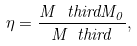<formula> <loc_0><loc_0><loc_500><loc_500>\eta = \frac { M ^ { \ } t h i r d M _ { 0 } } { M _ { \ } t h i r d } ,</formula> 